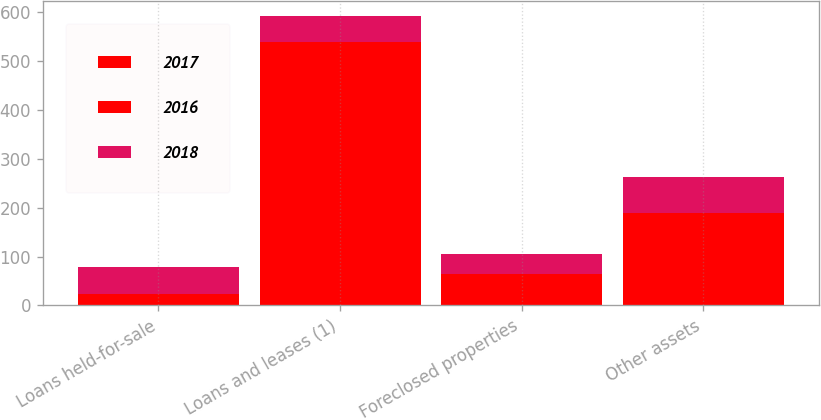<chart> <loc_0><loc_0><loc_500><loc_500><stacked_bar_chart><ecel><fcel>Loans held-for-sale<fcel>Loans and leases (1)<fcel>Foreclosed properties<fcel>Other assets<nl><fcel>2017<fcel>18<fcel>202<fcel>24<fcel>64<nl><fcel>2016<fcel>6<fcel>336<fcel>41<fcel>124<nl><fcel>2018<fcel>54<fcel>54<fcel>41<fcel>74<nl></chart> 